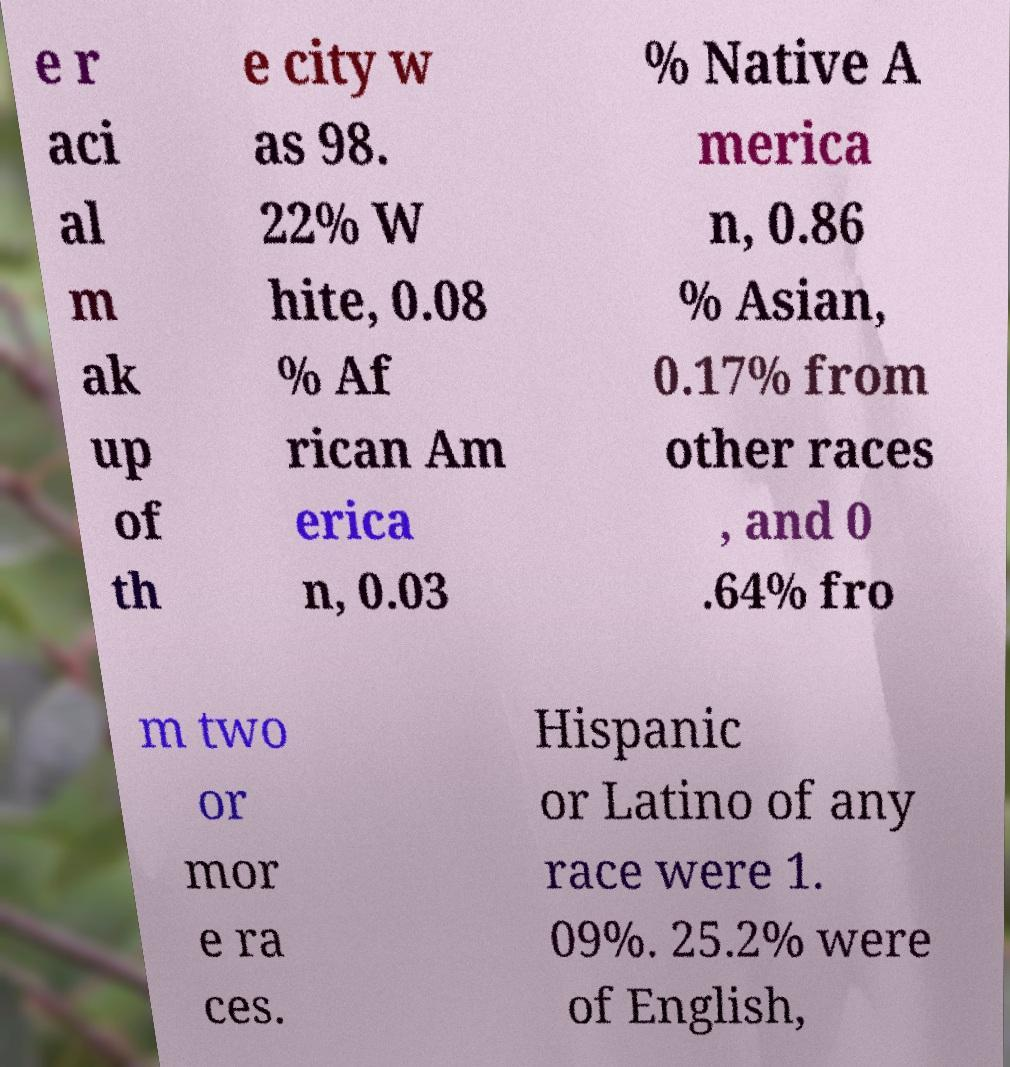What messages or text are displayed in this image? I need them in a readable, typed format. e r aci al m ak up of th e city w as 98. 22% W hite, 0.08 % Af rican Am erica n, 0.03 % Native A merica n, 0.86 % Asian, 0.17% from other races , and 0 .64% fro m two or mor e ra ces. Hispanic or Latino of any race were 1. 09%. 25.2% were of English, 